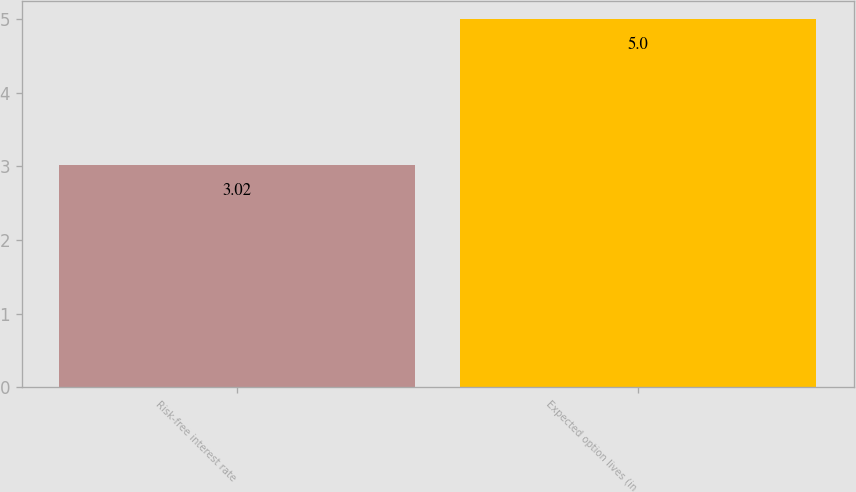Convert chart. <chart><loc_0><loc_0><loc_500><loc_500><bar_chart><fcel>Risk-free interest rate<fcel>Expected option lives (in<nl><fcel>3.02<fcel>5<nl></chart> 